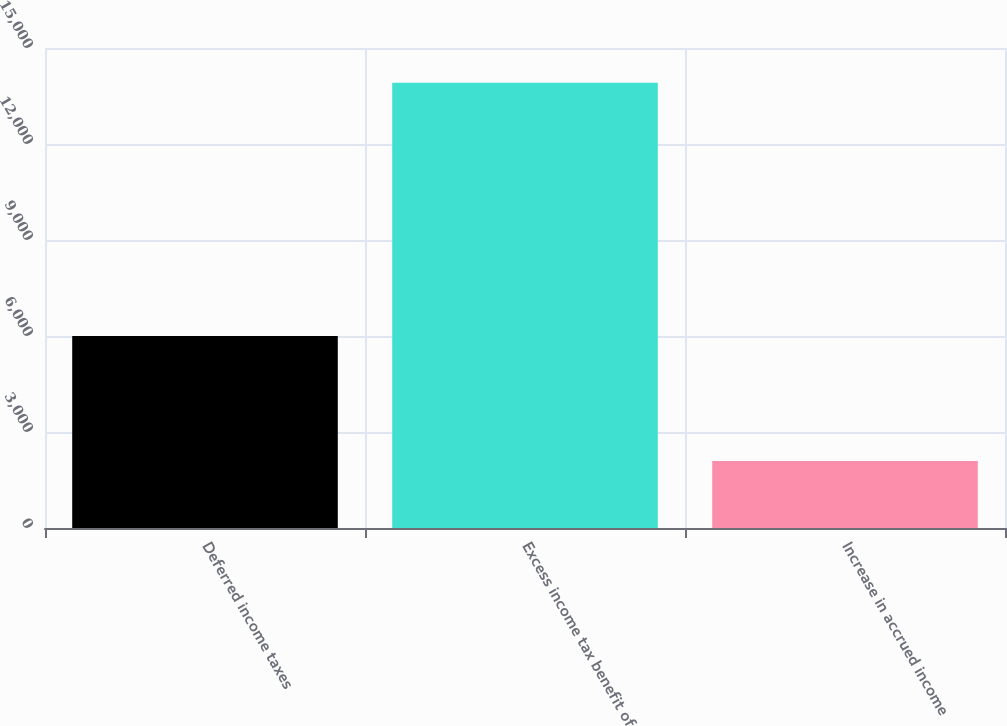Convert chart. <chart><loc_0><loc_0><loc_500><loc_500><bar_chart><fcel>Deferred income taxes<fcel>Excess income tax benefit of<fcel>Increase in accrued income<nl><fcel>6000<fcel>13916<fcel>2090<nl></chart> 